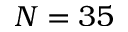<formula> <loc_0><loc_0><loc_500><loc_500>N = 3 5</formula> 